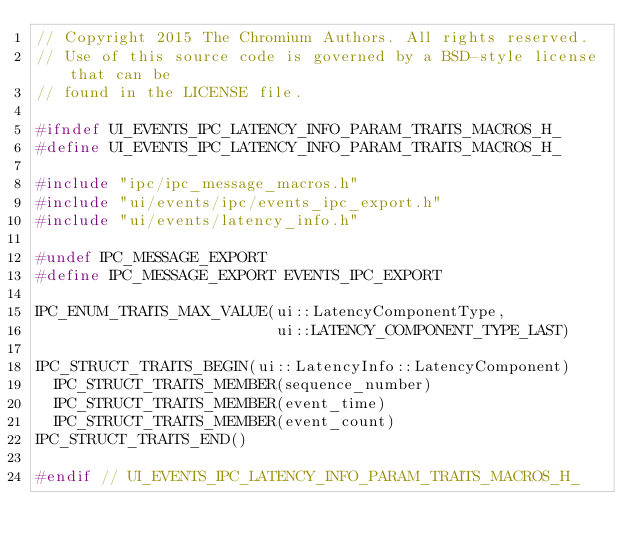Convert code to text. <code><loc_0><loc_0><loc_500><loc_500><_C_>// Copyright 2015 The Chromium Authors. All rights reserved.
// Use of this source code is governed by a BSD-style license that can be
// found in the LICENSE file.

#ifndef UI_EVENTS_IPC_LATENCY_INFO_PARAM_TRAITS_MACROS_H_
#define UI_EVENTS_IPC_LATENCY_INFO_PARAM_TRAITS_MACROS_H_

#include "ipc/ipc_message_macros.h"
#include "ui/events/ipc/events_ipc_export.h"
#include "ui/events/latency_info.h"

#undef IPC_MESSAGE_EXPORT
#define IPC_MESSAGE_EXPORT EVENTS_IPC_EXPORT

IPC_ENUM_TRAITS_MAX_VALUE(ui::LatencyComponentType,
                          ui::LATENCY_COMPONENT_TYPE_LAST)

IPC_STRUCT_TRAITS_BEGIN(ui::LatencyInfo::LatencyComponent)
  IPC_STRUCT_TRAITS_MEMBER(sequence_number)
  IPC_STRUCT_TRAITS_MEMBER(event_time)
  IPC_STRUCT_TRAITS_MEMBER(event_count)
IPC_STRUCT_TRAITS_END()

#endif // UI_EVENTS_IPC_LATENCY_INFO_PARAM_TRAITS_MACROS_H_
</code> 